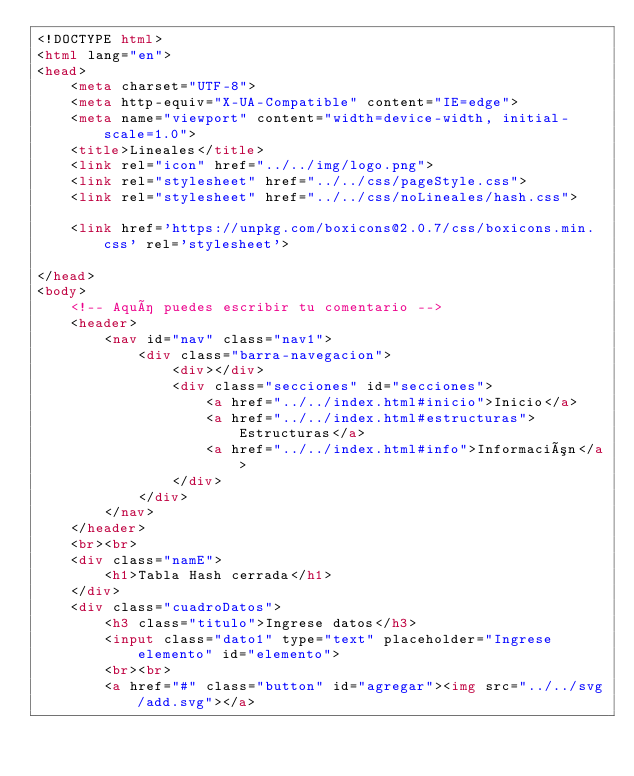Convert code to text. <code><loc_0><loc_0><loc_500><loc_500><_HTML_><!DOCTYPE html>
<html lang="en">
<head>
    <meta charset="UTF-8">
    <meta http-equiv="X-UA-Compatible" content="IE=edge">
    <meta name="viewport" content="width=device-width, initial-scale=1.0">
    <title>Lineales</title>
    <link rel="icon" href="../../img/logo.png">
    <link rel="stylesheet" href="../../css/pageStyle.css">
    <link rel="stylesheet" href="../../css/noLineales/hash.css">
    
    <link href='https://unpkg.com/boxicons@2.0.7/css/boxicons.min.css' rel='stylesheet'>

</head>
<body>
    <!-- Aquí puedes escribir tu comentario -->
    <header>
        <nav id="nav" class="nav1">
            <div class="barra-navegacion">
                <div></div>
                <div class="secciones" id="secciones">
                    <a href="../../index.html#inicio">Inicio</a>
                    <a href="../../index.html#estructuras">Estructuras</a>
                    <a href="../../index.html#info">Información</a>
                </div>
            </div>
        </nav>
    </header>
    <br><br>
    <div class="namE">
        <h1>Tabla Hash cerrada</h1>
    </div>    
    <div class="cuadroDatos">
        <h3 class="titulo">Ingrese datos</h3>
        <input class="dato1" type="text" placeholder="Ingrese elemento" id="elemento">
        <br><br>
        <a href="#" class="button" id="agregar"><img src="../../svg/add.svg"></a></code> 